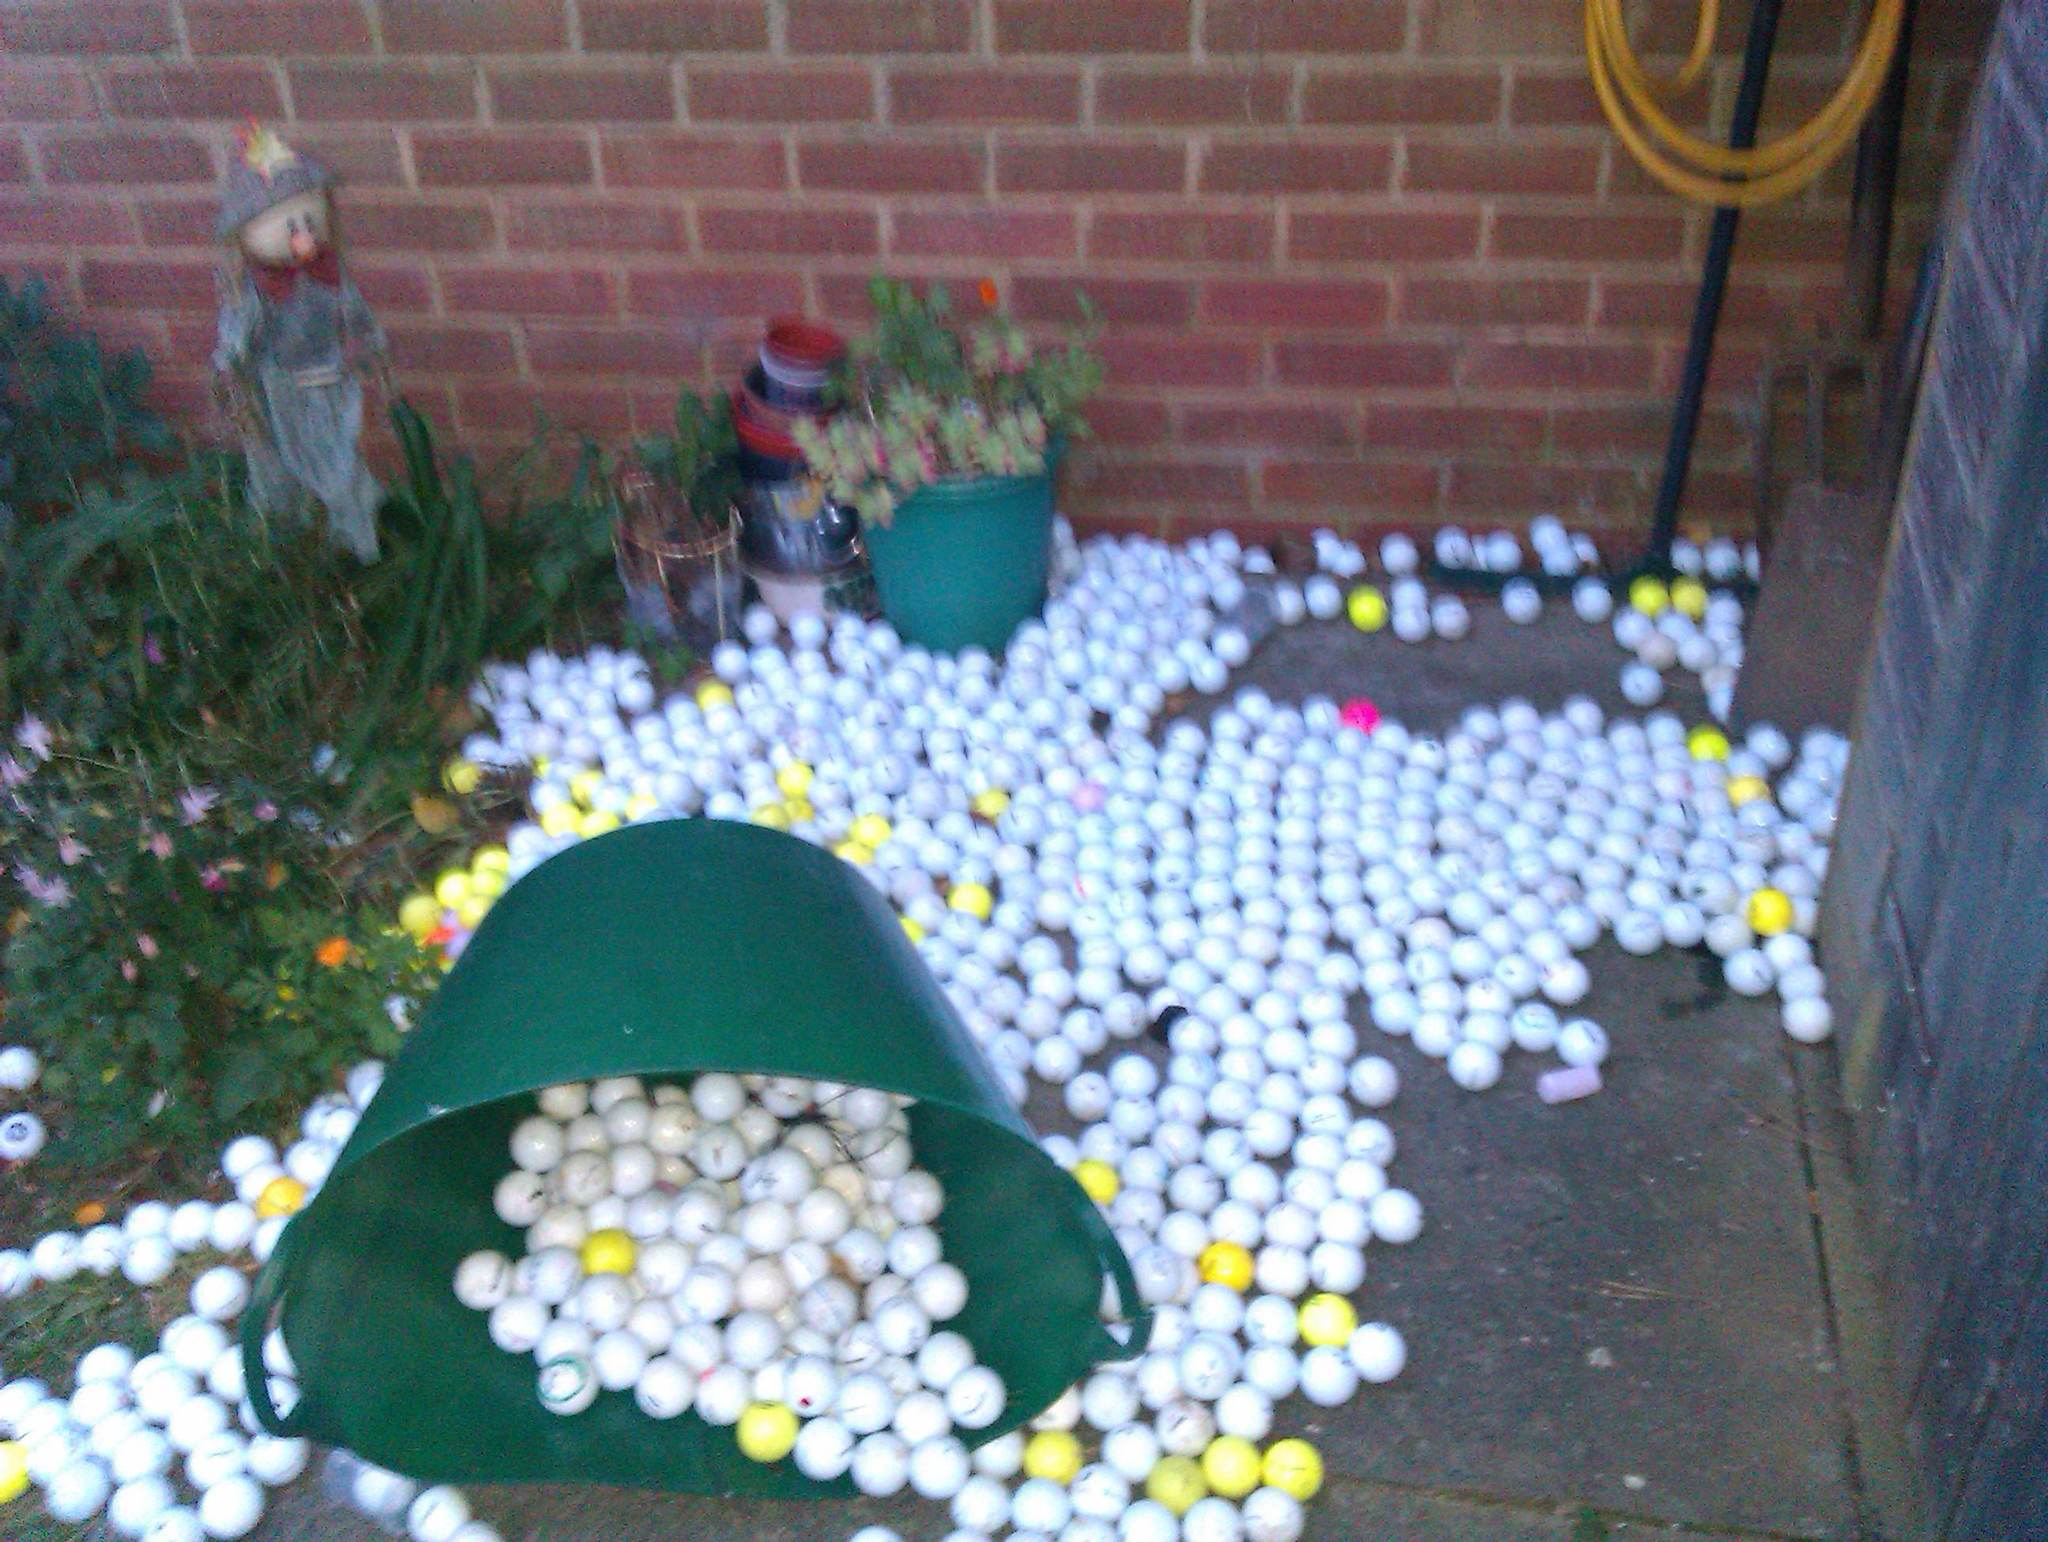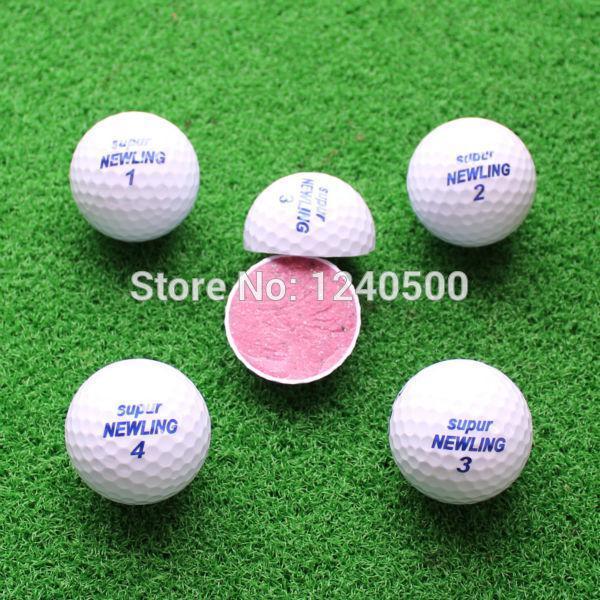The first image is the image on the left, the second image is the image on the right. Examine the images to the left and right. Is the description "One image shows gift wrapped golf balls." accurate? Answer yes or no. No. The first image is the image on the left, the second image is the image on the right. Examine the images to the left and right. Is the description "Multiple people are standing on green grass in one of the golf-themed images." accurate? Answer yes or no. No. 